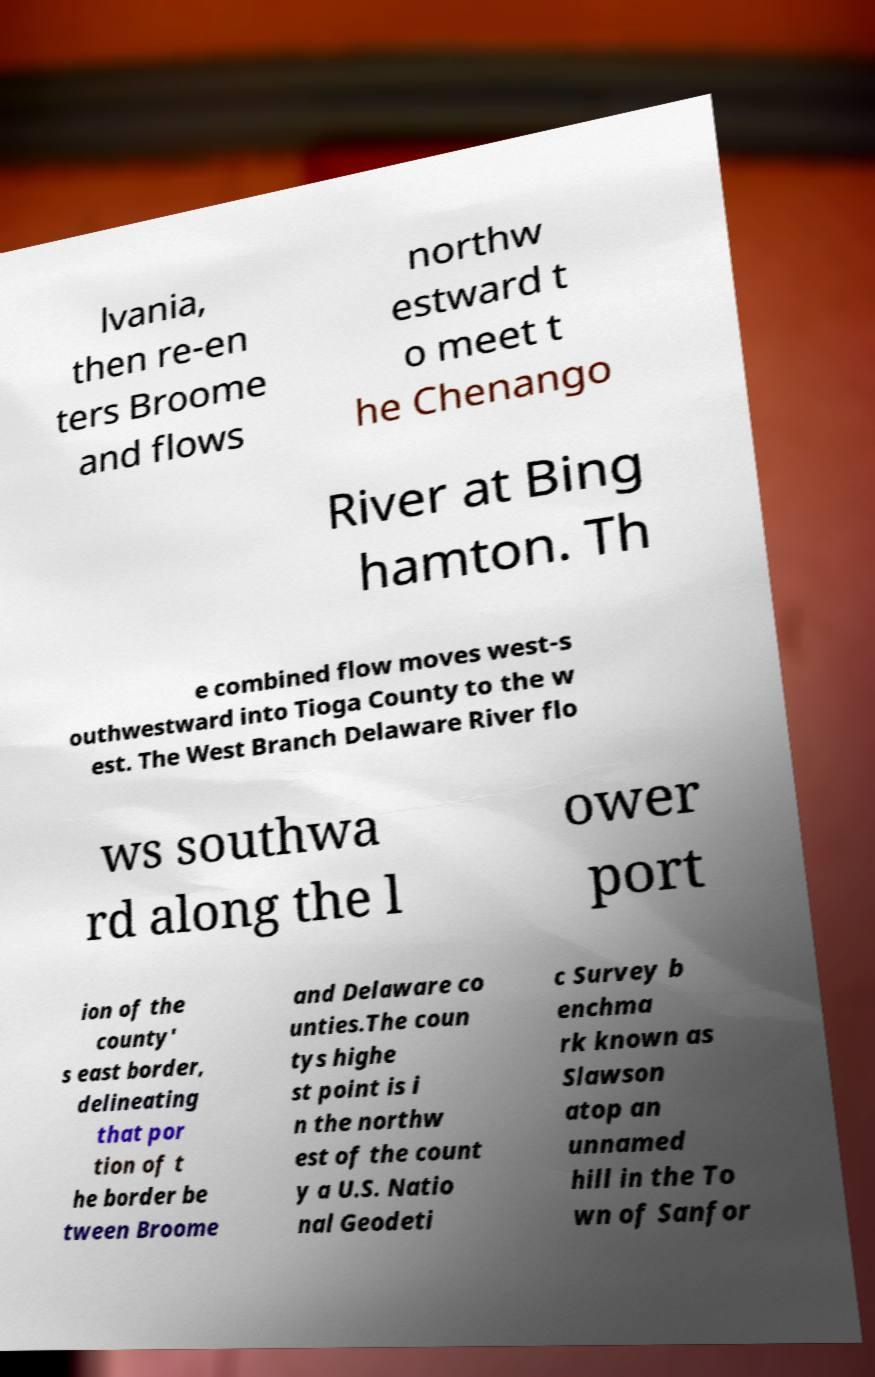There's text embedded in this image that I need extracted. Can you transcribe it verbatim? lvania, then re-en ters Broome and flows northw estward t o meet t he Chenango River at Bing hamton. Th e combined flow moves west-s outhwestward into Tioga County to the w est. The West Branch Delaware River flo ws southwa rd along the l ower port ion of the county' s east border, delineating that por tion of t he border be tween Broome and Delaware co unties.The coun tys highe st point is i n the northw est of the count y a U.S. Natio nal Geodeti c Survey b enchma rk known as Slawson atop an unnamed hill in the To wn of Sanfor 